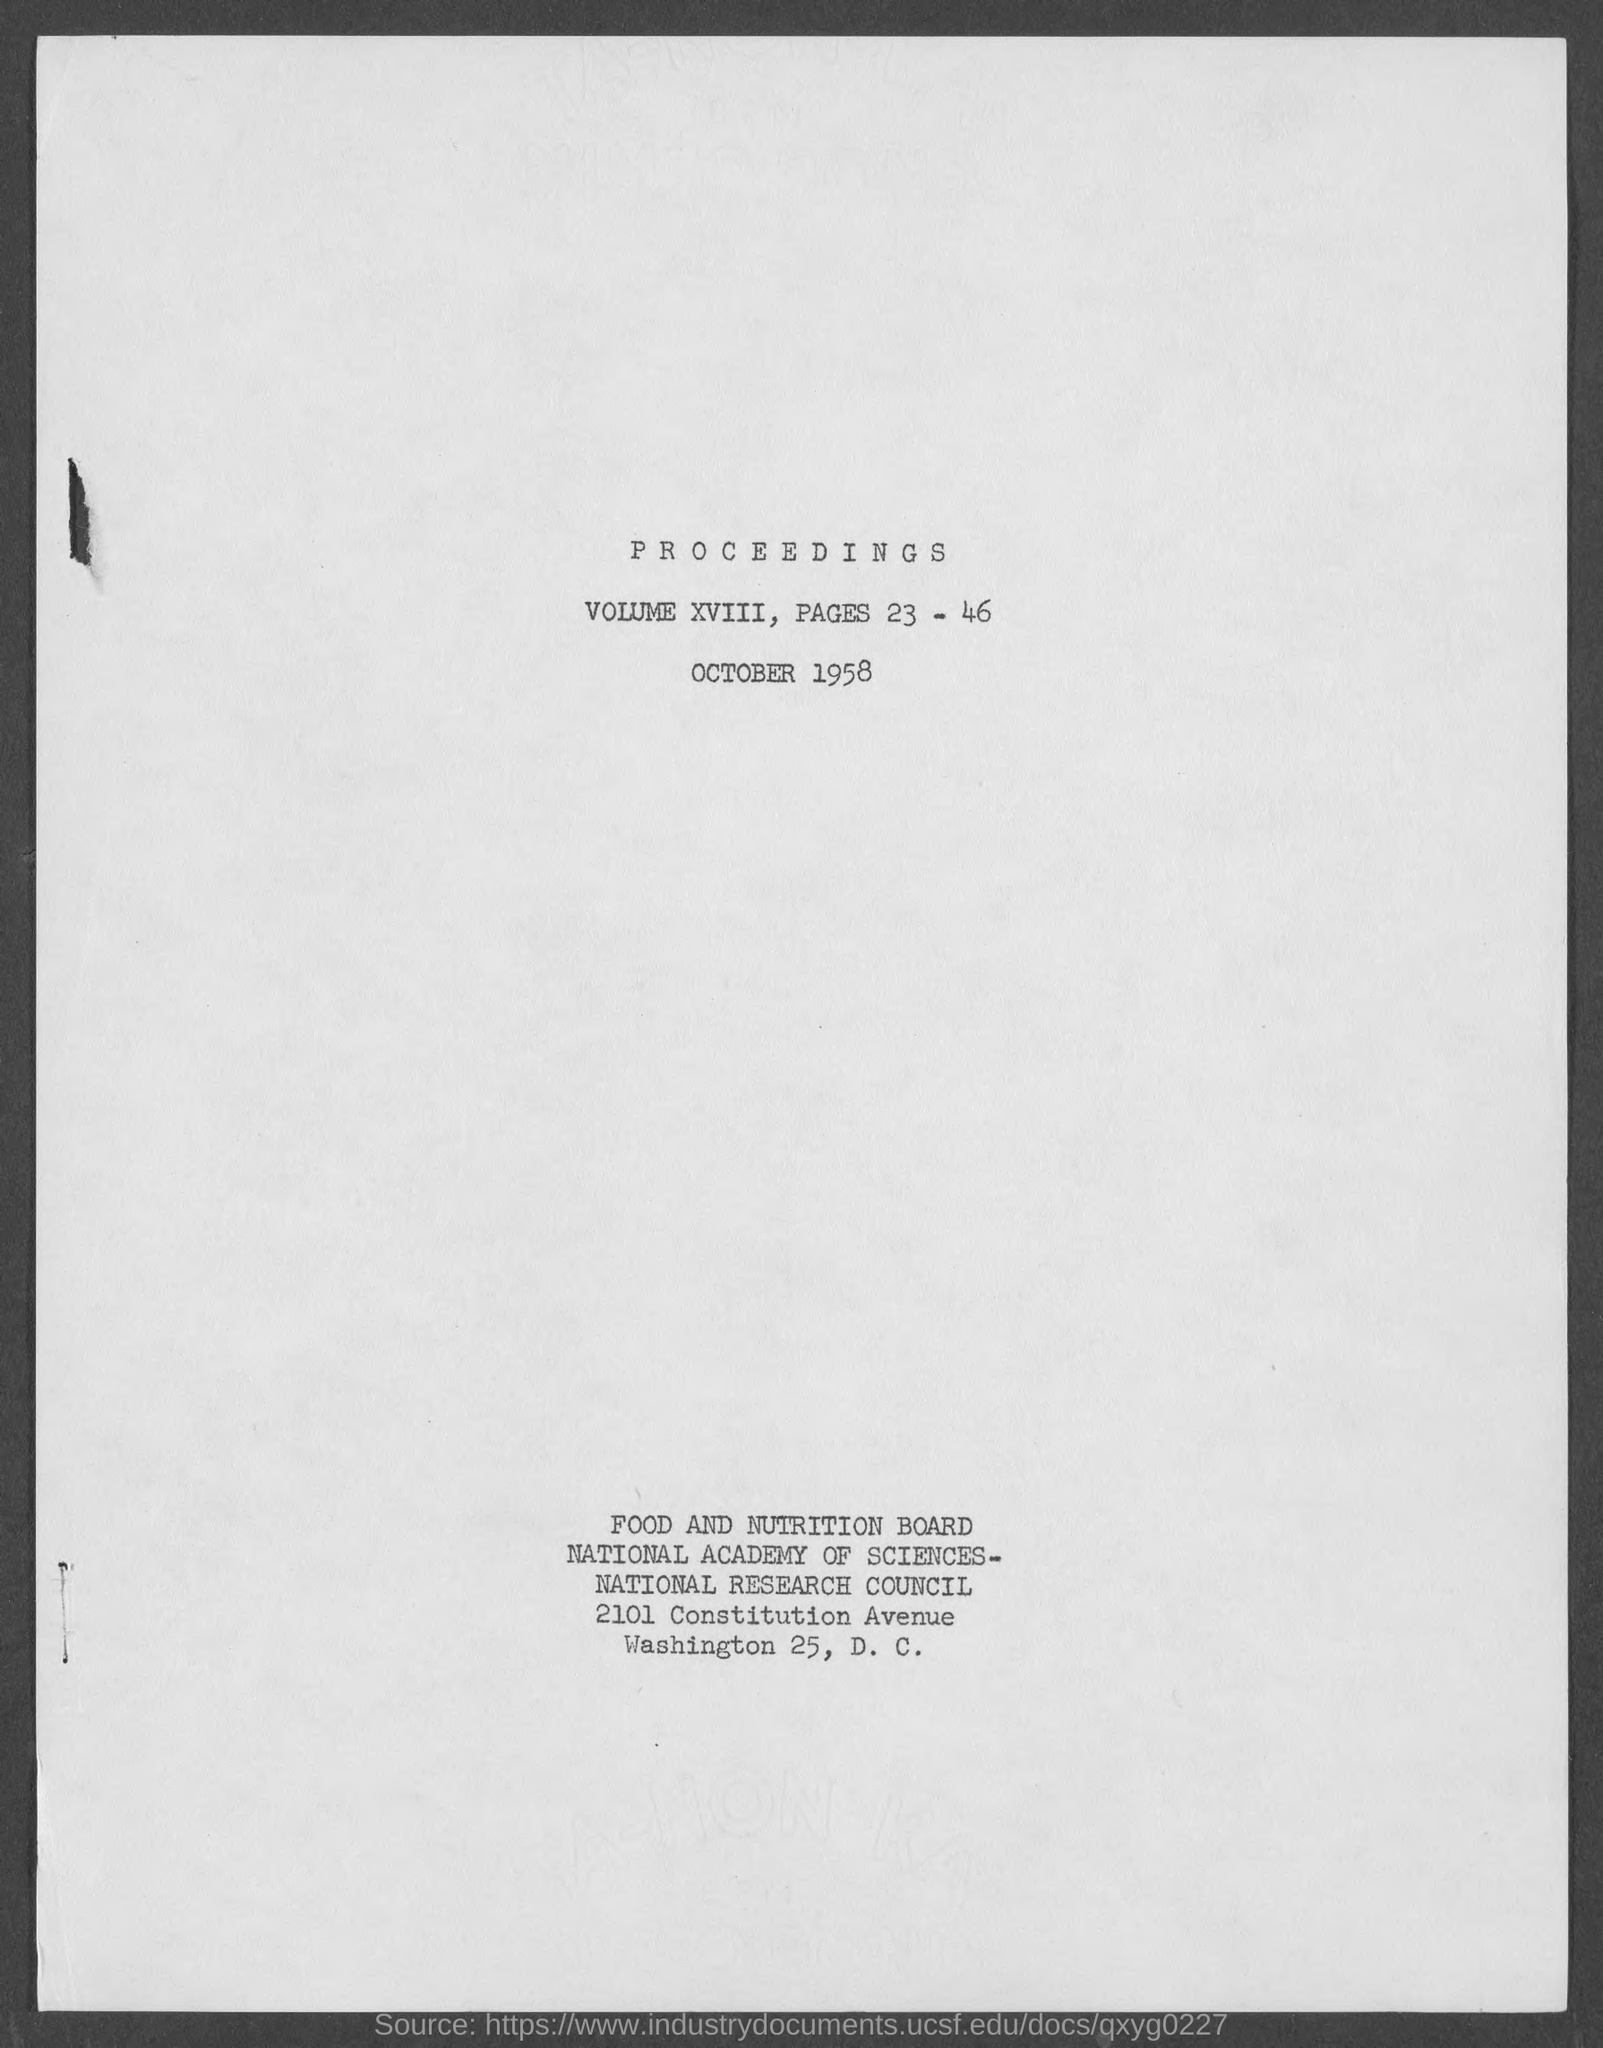Draw attention to some important aspects in this diagram. The volume number for the Proceedings is XVIII. The page number issued for the Proceedings is 23 to 46. The date mentioned in the Proceedings is October 1958. 